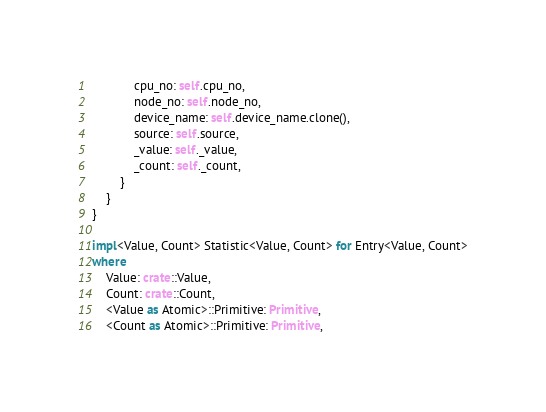<code> <loc_0><loc_0><loc_500><loc_500><_Rust_>            cpu_no: self.cpu_no,
            node_no: self.node_no,
            device_name: self.device_name.clone(),
            source: self.source,
            _value: self._value,
            _count: self._count,
        }
    }
}

impl<Value, Count> Statistic<Value, Count> for Entry<Value, Count>
where
    Value: crate::Value,
    Count: crate::Count,
    <Value as Atomic>::Primitive: Primitive,
    <Count as Atomic>::Primitive: Primitive,</code> 